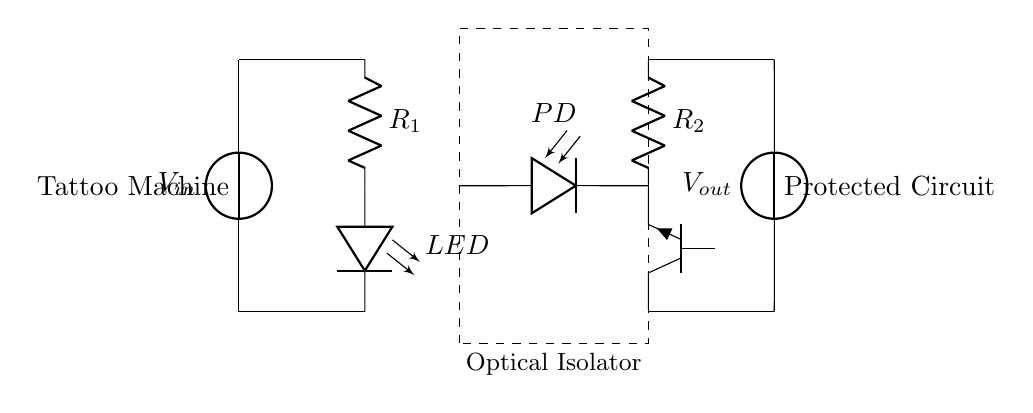What is the type of the main component in the optical isolator? The main component in the optical isolator is a photodiode, indicated in the circuit.
Answer: photodiode What does the resistor R1 connect to? Resistor R1 is connected to the LED and the voltage source, forming the input side of the circuit.
Answer: LED and V source What is the purpose of the optical isolator in this circuit? The optical isolator protects sensitive electronics from noise or interference generated by the tattoo machine.
Answer: Protection How many resistors are present in the circuit? There are two resistors, R1 and R2, which are essential components in this amplifier circuit.
Answer: 2 What is the output voltage labeled as in this circuit? The output voltage is labeled as V out, which signifies the output potential of the circuit.
Answer: V out What component is located after the optical isolator? The component located after the optical isolator is the NPN transistor, which is used for amplification.
Answer: NPN transistor What is the function of the LED in this circuit? The LED serves as an indicator showing that the circuit is active, providing a visual cue for operation status.
Answer: Indicator 